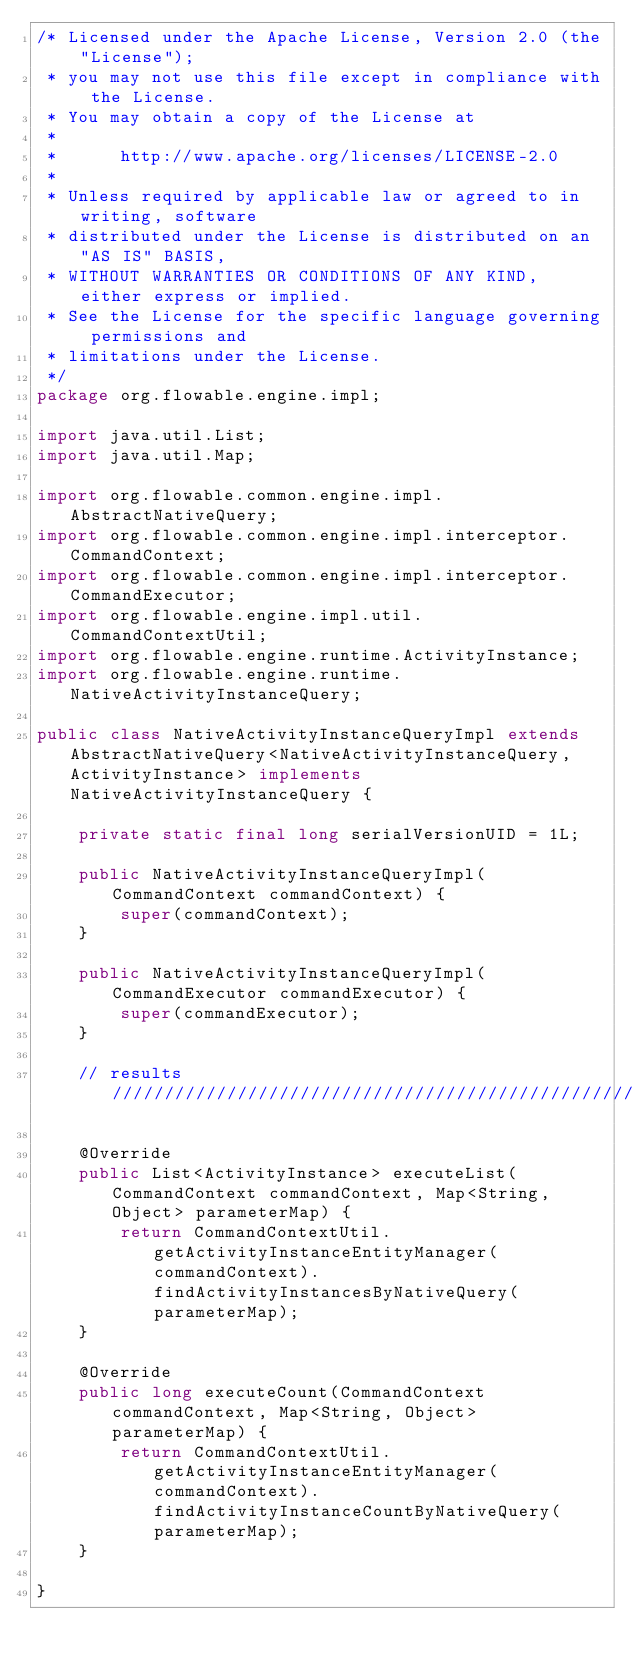Convert code to text. <code><loc_0><loc_0><loc_500><loc_500><_Java_>/* Licensed under the Apache License, Version 2.0 (the "License");
 * you may not use this file except in compliance with the License.
 * You may obtain a copy of the License at
 * 
 *      http://www.apache.org/licenses/LICENSE-2.0
 * 
 * Unless required by applicable law or agreed to in writing, software
 * distributed under the License is distributed on an "AS IS" BASIS,
 * WITHOUT WARRANTIES OR CONDITIONS OF ANY KIND, either express or implied.
 * See the License for the specific language governing permissions and
 * limitations under the License.
 */
package org.flowable.engine.impl;

import java.util.List;
import java.util.Map;

import org.flowable.common.engine.impl.AbstractNativeQuery;
import org.flowable.common.engine.impl.interceptor.CommandContext;
import org.flowable.common.engine.impl.interceptor.CommandExecutor;
import org.flowable.engine.impl.util.CommandContextUtil;
import org.flowable.engine.runtime.ActivityInstance;
import org.flowable.engine.runtime.NativeActivityInstanceQuery;

public class NativeActivityInstanceQueryImpl extends AbstractNativeQuery<NativeActivityInstanceQuery, ActivityInstance> implements NativeActivityInstanceQuery {

    private static final long serialVersionUID = 1L;

    public NativeActivityInstanceQueryImpl(CommandContext commandContext) {
        super(commandContext);
    }

    public NativeActivityInstanceQueryImpl(CommandExecutor commandExecutor) {
        super(commandExecutor);
    }

    // results ////////////////////////////////////////////////////////////////

    @Override
    public List<ActivityInstance> executeList(CommandContext commandContext, Map<String, Object> parameterMap) {
        return CommandContextUtil.getActivityInstanceEntityManager(commandContext).findActivityInstancesByNativeQuery(parameterMap);
    }

    @Override
    public long executeCount(CommandContext commandContext, Map<String, Object> parameterMap) {
        return CommandContextUtil.getActivityInstanceEntityManager(commandContext).findActivityInstanceCountByNativeQuery(parameterMap);
    }

}
</code> 